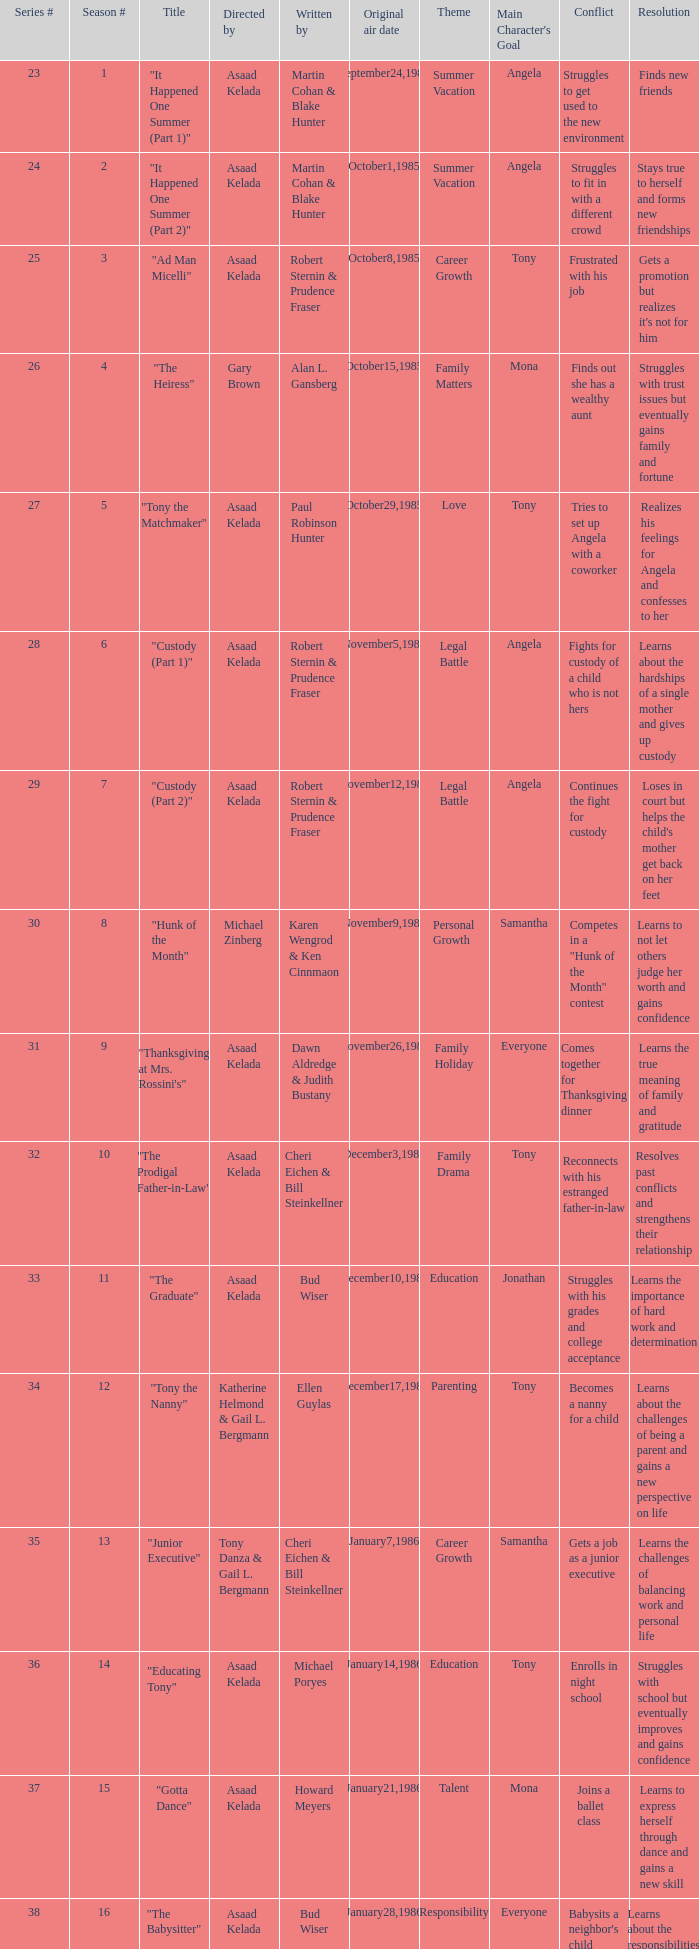Parse the full table. {'header': ['Series #', 'Season #', 'Title', 'Directed by', 'Written by', 'Original air date', 'Theme', "Main Character's Goal", 'Conflict', 'Resolution'], 'rows': [['23', '1', '"It Happened One Summer (Part 1)"', 'Asaad Kelada', 'Martin Cohan & Blake Hunter', 'September24,1985', 'Summer Vacation', 'Angela', 'Struggles to get used to the new environment', 'Finds new friends'], ['24', '2', '"It Happened One Summer (Part 2)"', 'Asaad Kelada', 'Martin Cohan & Blake Hunter', 'October1,1985', 'Summer Vacation', 'Angela', 'Struggles to fit in with a different crowd', 'Stays true to herself and forms new friendships'], ['25', '3', '"Ad Man Micelli"', 'Asaad Kelada', 'Robert Sternin & Prudence Fraser', 'October8,1985', 'Career Growth', 'Tony', 'Frustrated with his job', "Gets a promotion but realizes it's not for him"], ['26', '4', '"The Heiress"', 'Gary Brown', 'Alan L. Gansberg', 'October15,1985', 'Family Matters', 'Mona', 'Finds out she has a wealthy aunt', 'Struggles with trust issues but eventually gains family and fortune'], ['27', '5', '"Tony the Matchmaker"', 'Asaad Kelada', 'Paul Robinson Hunter', 'October29,1985', 'Love', 'Tony', 'Tries to set up Angela with a coworker', 'Realizes his feelings for Angela and confesses to her'], ['28', '6', '"Custody (Part 1)"', 'Asaad Kelada', 'Robert Sternin & Prudence Fraser', 'November5,1985', 'Legal Battle', 'Angela', 'Fights for custody of a child who is not hers', 'Learns about the hardships of a single mother and gives up custody'], ['29', '7', '"Custody (Part 2)"', 'Asaad Kelada', 'Robert Sternin & Prudence Fraser', 'November12,1985', 'Legal Battle', 'Angela', 'Continues the fight for custody', "Loses in court but helps the child's mother get back on her feet"], ['30', '8', '"Hunk of the Month"', 'Michael Zinberg', 'Karen Wengrod & Ken Cinnmaon', 'November9,1985', 'Personal Growth', 'Samantha', 'Competes in a "Hunk of the Month" contest', 'Learns to not let others judge her worth and gains confidence'], ['31', '9', '"Thanksgiving at Mrs. Rossini\'s"', 'Asaad Kelada', 'Dawn Aldredge & Judith Bustany', 'November26,1985', 'Family Holiday', 'Everyone', 'Comes together for Thanksgiving dinner', 'Learns the true meaning of family and gratitude'], ['32', '10', '"The Prodigal Father-in-Law"', 'Asaad Kelada', 'Cheri Eichen & Bill Steinkellner', 'December3,1985', 'Family Drama', 'Tony', 'Reconnects with his estranged father-in-law', 'Resolves past conflicts and strengthens their relationship'], ['33', '11', '"The Graduate"', 'Asaad Kelada', 'Bud Wiser', 'December10,1985', 'Education', 'Jonathan', 'Struggles with his grades and college acceptance', 'Learns the importance of hard work and determination'], ['34', '12', '"Tony the Nanny"', 'Katherine Helmond & Gail L. Bergmann', 'Ellen Guylas', 'December17,1985', 'Parenting', 'Tony', 'Becomes a nanny for a child', 'Learns about the challenges of being a parent and gains a new perspective on life'], ['35', '13', '"Junior Executive"', 'Tony Danza & Gail L. Bergmann', 'Cheri Eichen & Bill Steinkellner', 'January7,1986', 'Career Growth', 'Samantha', 'Gets a job as a junior executive', 'Learns the challenges of balancing work and personal life'], ['36', '14', '"Educating Tony"', 'Asaad Kelada', 'Michael Poryes', 'January14,1986', 'Education', 'Tony', 'Enrolls in night school', 'Struggles with school but eventually improves and gains confidence'], ['37', '15', '"Gotta Dance"', 'Asaad Kelada', 'Howard Meyers', 'January21,1986', 'Talent', 'Mona', 'Joins a ballet class', 'Learns to express herself through dance and gains a new skill'], ['38', '16', '"The Babysitter"', 'Asaad Kelada', 'Bud Wiser', 'January28,1986', 'Responsibility', 'Everyone', "Babysits a neighbor's child", 'Learns about the responsibilities of parenting and gains a newfound appreciation for children'], ['39', '17', '"Jonathan Plays Cupid "', 'Asaad Kelada', 'Paul Robinson Hunter', 'February11,1986', 'Love', 'Jonathan', 'Plays matchmaker for a friend', 'Learns about the power of love and helps his friend find happiness'], ['40', '18', '"When Worlds Collide"', 'Asaad Kelada', 'Karen Wengrod & Ken Cinnamon', 'February18,1986', 'Culture Clash', 'Everyone', "Meets Angela's Italian family", 'Learns about different cultures and the importance of acceptance'], ['41', '19', '"Losers and Other Strangers"', 'Asaad Kelada', 'Seth Weisbord', 'February25,1986', 'Personal Growth', 'Everyone', 'Deals with personal struggles', 'Learns to support each other and grow together'], ['42', '20', '"Tony for President"', 'Asaad Kelada', 'Howard Meyers', 'March4,1986', 'Politics', 'Tony', 'Runs for office in a local election', 'Learns about politics and the importance of honesty in leadership'], ['43', '21', '"Not With My Client, You Don\'t"', 'Asaad Kelada', 'Dawn Aldredge & Judith Bustany', 'March18,1986', 'Legal Battle', 'Angela', 'Represents a difficult client in court', 'Learns about the challenges of being a lawyer and the importance of upholding justice'], ['45', '23', '"There\'s No Business Like Shoe Business"', 'Asaad Kelada', 'Karen Wengrod & Ken Cinnamon', 'April1,1986', 'Career Growth', 'Mona', 'Starts her own business selling shoes', 'Faces challenges but ultimately succeeds and grows professionally'], ['46', '24', '"The Unnatural"', 'Jim Drake', 'Ellen Guylas', 'April8,1986', 'Sports', 'Tony', 'Joins a softball team', 'Struggles at first but eventually improves and gains a newfound love for the sport.']]} What season features writer Michael Poryes? 14.0. 